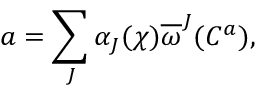Convert formula to latex. <formula><loc_0><loc_0><loc_500><loc_500>a = \sum _ { J } \alpha _ { J } ( \chi ) \overline { \omega } ^ { J } ( C ^ { a } ) ,</formula> 